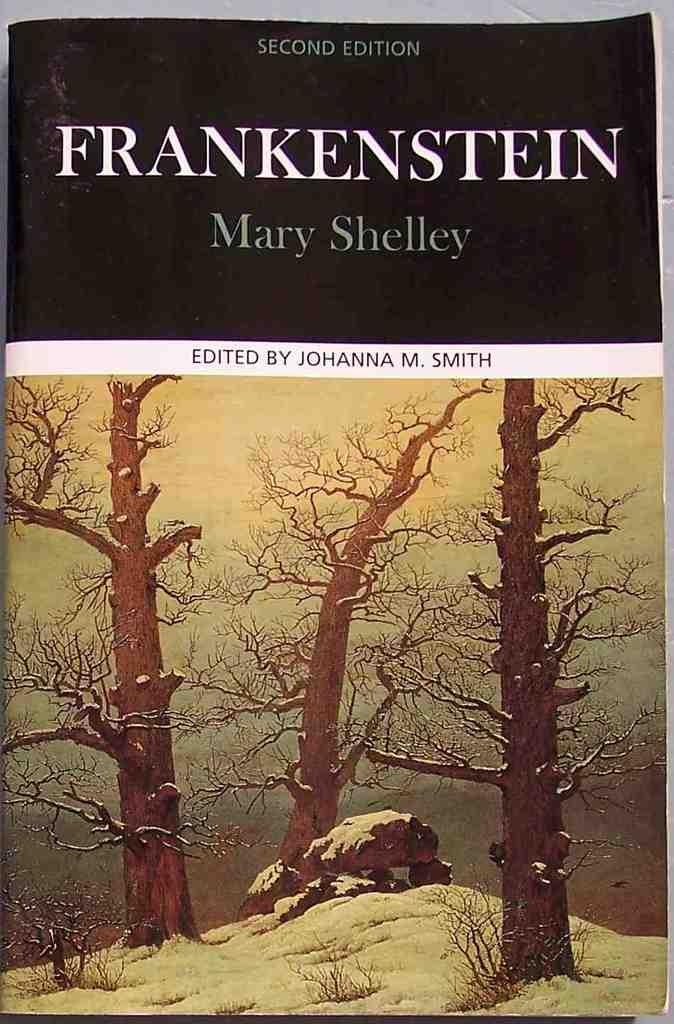What is the main subject of the image? The main subject of the image is a book cover. What natural elements can be seen in the image? There are three trees and a rock visible in the image. Is there any text present in the image? Yes, there is some text visible in the image. How is the rifle being distributed among the trees in the image? There is no rifle present in the image; it only features a book cover, trees, a rock, and some text. 